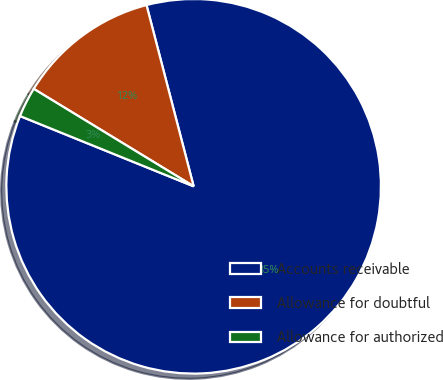<chart> <loc_0><loc_0><loc_500><loc_500><pie_chart><fcel>Accounts receivable<fcel>Allowance for doubtful<fcel>Allowance for authorized<nl><fcel>85.17%<fcel>12.24%<fcel>2.59%<nl></chart> 